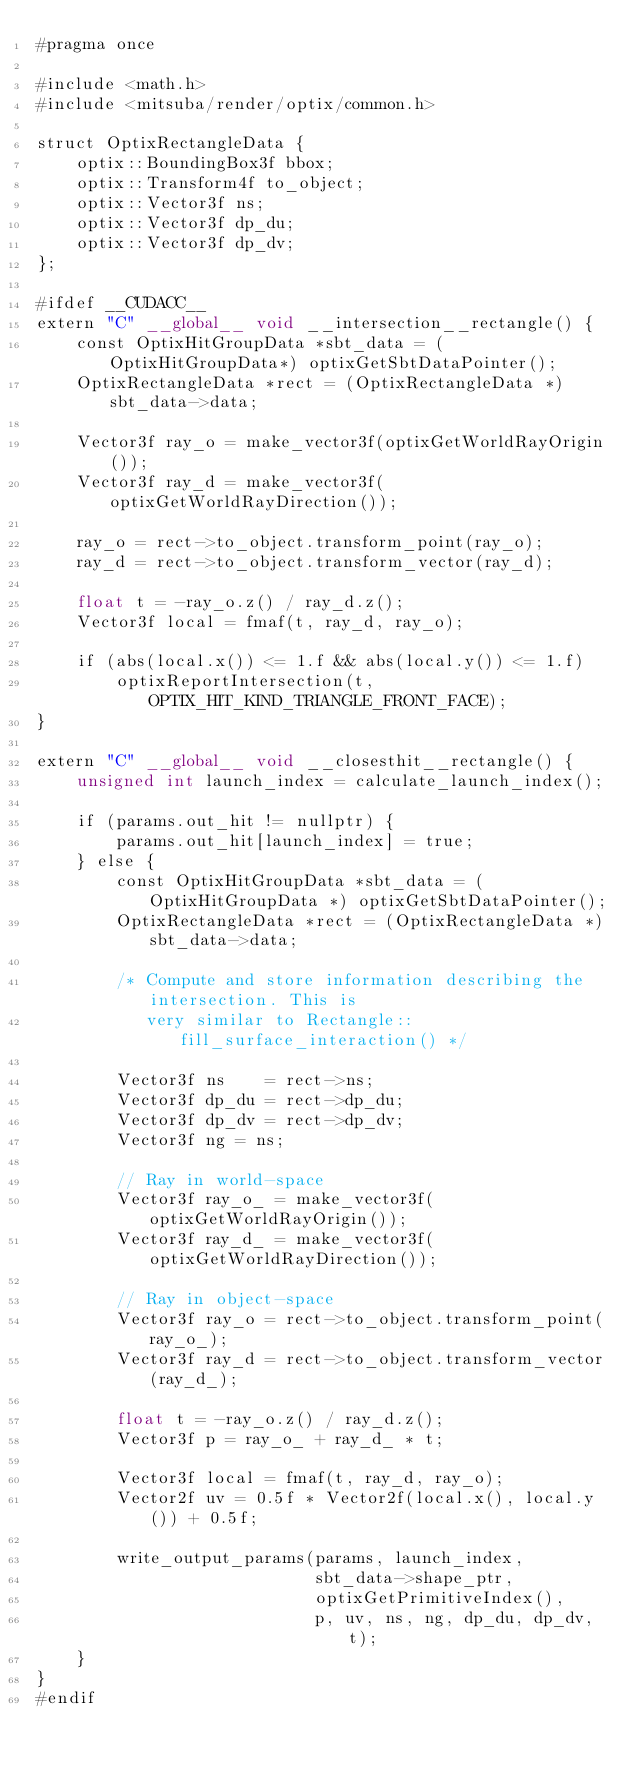<code> <loc_0><loc_0><loc_500><loc_500><_Cuda_>#pragma once

#include <math.h>
#include <mitsuba/render/optix/common.h>

struct OptixRectangleData {
    optix::BoundingBox3f bbox;
    optix::Transform4f to_object;
    optix::Vector3f ns;
    optix::Vector3f dp_du;
    optix::Vector3f dp_dv;
};

#ifdef __CUDACC__
extern "C" __global__ void __intersection__rectangle() {
    const OptixHitGroupData *sbt_data = (OptixHitGroupData*) optixGetSbtDataPointer();
    OptixRectangleData *rect = (OptixRectangleData *)sbt_data->data;

    Vector3f ray_o = make_vector3f(optixGetWorldRayOrigin());
    Vector3f ray_d = make_vector3f(optixGetWorldRayDirection());

    ray_o = rect->to_object.transform_point(ray_o);
    ray_d = rect->to_object.transform_vector(ray_d);

    float t = -ray_o.z() / ray_d.z();
    Vector3f local = fmaf(t, ray_d, ray_o);

    if (abs(local.x()) <= 1.f && abs(local.y()) <= 1.f)
        optixReportIntersection(t, OPTIX_HIT_KIND_TRIANGLE_FRONT_FACE);
}

extern "C" __global__ void __closesthit__rectangle() {
    unsigned int launch_index = calculate_launch_index();

    if (params.out_hit != nullptr) {
        params.out_hit[launch_index] = true;
    } else {
        const OptixHitGroupData *sbt_data = (OptixHitGroupData *) optixGetSbtDataPointer();
        OptixRectangleData *rect = (OptixRectangleData *)sbt_data->data;

        /* Compute and store information describing the intersection. This is
           very similar to Rectangle::fill_surface_interaction() */

        Vector3f ns    = rect->ns;
        Vector3f dp_du = rect->dp_du;
        Vector3f dp_dv = rect->dp_dv;
        Vector3f ng = ns;

        // Ray in world-space
        Vector3f ray_o_ = make_vector3f(optixGetWorldRayOrigin());
        Vector3f ray_d_ = make_vector3f(optixGetWorldRayDirection());

        // Ray in object-space
        Vector3f ray_o = rect->to_object.transform_point(ray_o_);
        Vector3f ray_d = rect->to_object.transform_vector(ray_d_);

        float t = -ray_o.z() / ray_d.z();
        Vector3f p = ray_o_ + ray_d_ * t;

        Vector3f local = fmaf(t, ray_d, ray_o);
        Vector2f uv = 0.5f * Vector2f(local.x(), local.y()) + 0.5f;

        write_output_params(params, launch_index,
                            sbt_data->shape_ptr,
                            optixGetPrimitiveIndex(),
                            p, uv, ns, ng, dp_du, dp_dv, t);
    }
}
#endif</code> 